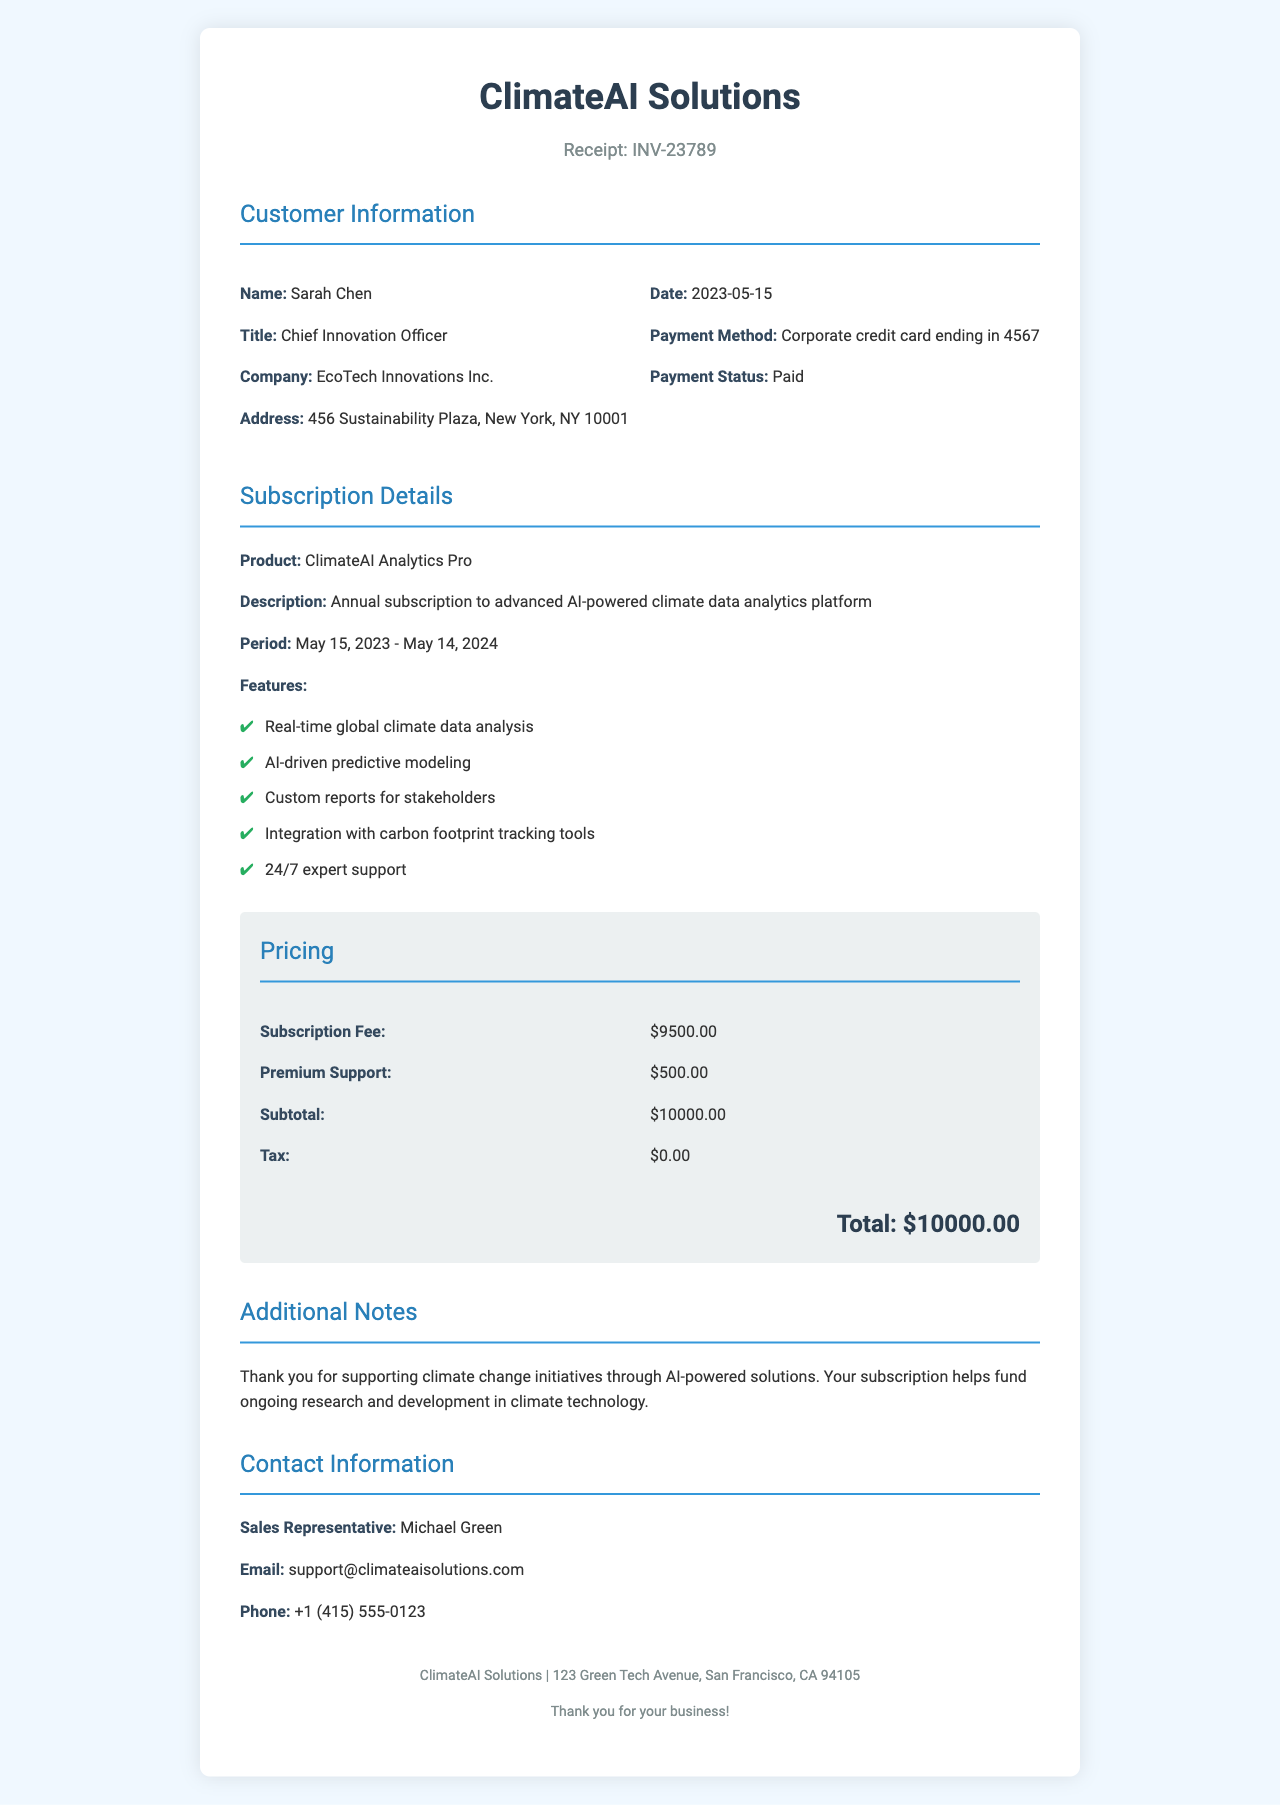What is the receipt number? The receipt number can be found in the header section of the document, labeled as "Receipt."
Answer: INV-23789 What is the subscription fee? The subscription fee is specified in the pricing section of the document.
Answer: $9500.00 Who is the sales representative? The sales representative's name is listed in the contact information section of the document.
Answer: Michael Green What is the total amount charged? The total amount charged is provided at the bottom of the pricing section as the final total.
Answer: $10000.00 What is the duration of the subscription? The subscription period is mentioned in the subscription details section.
Answer: May 15, 2023 - May 14, 2024 What company provides the subscription service? The company providing the subscription is clearly stated at the top of the receipt.
Answer: ClimateAI Solutions What method of payment was used? The payment method can be found in the customer information section of the document.
Answer: Corporate credit card ending in 4567 What features are included with the subscription? The features are listed in the subscription details section, highlighting the capabilities of the product.
Answer: Real-time global climate data analysis, AI-driven predictive modeling, Custom reports for stakeholders, Integration with carbon footprint tracking tools, 24/7 expert support What is the additional note regarding the subscription? The additional notes section contains a message regarding the impact of the subscription.
Answer: Thank you for supporting climate change initiatives through AI-powered solutions. Your subscription helps fund ongoing research and development in climate technology 